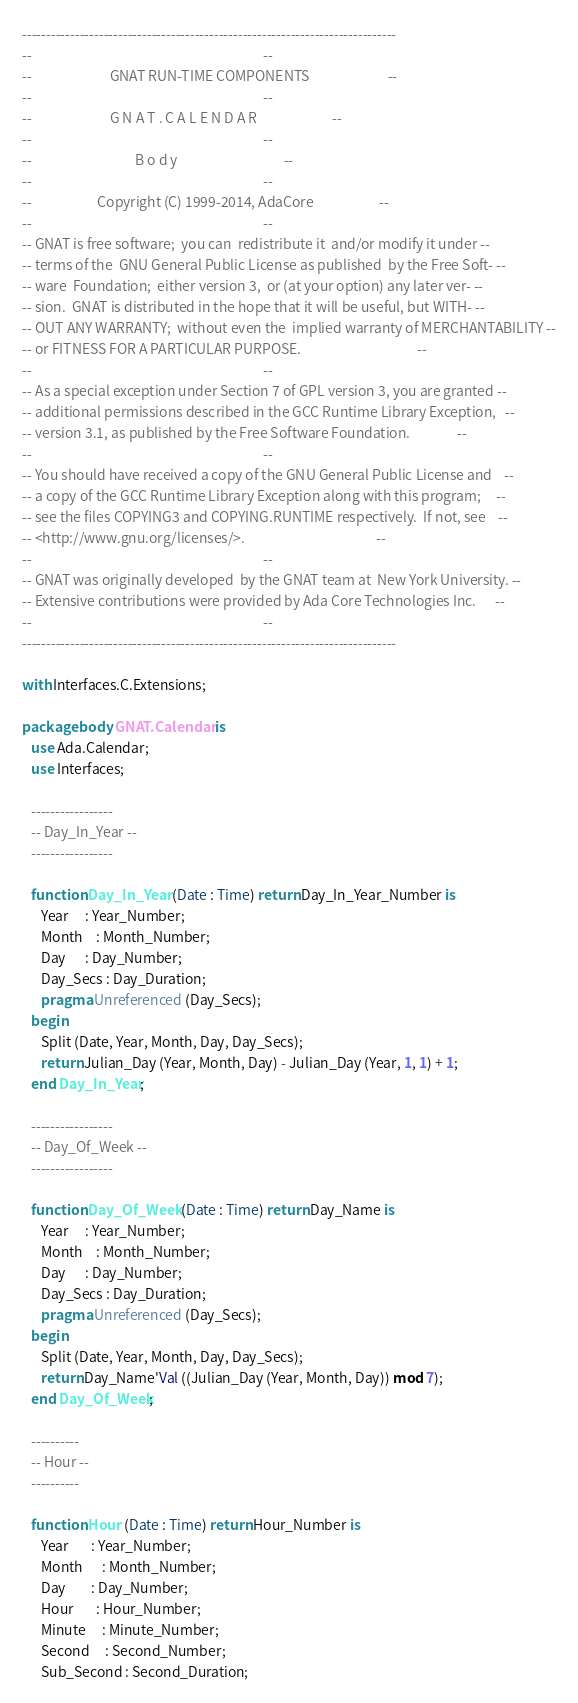<code> <loc_0><loc_0><loc_500><loc_500><_Ada_>------------------------------------------------------------------------------
--                                                                          --
--                         GNAT RUN-TIME COMPONENTS                         --
--                                                                          --
--                         G N A T . C A L E N D A R                        --
--                                                                          --
--                                 B o d y                                  --
--                                                                          --
--                     Copyright (C) 1999-2014, AdaCore                     --
--                                                                          --
-- GNAT is free software;  you can  redistribute it  and/or modify it under --
-- terms of the  GNU General Public License as published  by the Free Soft- --
-- ware  Foundation;  either version 3,  or (at your option) any later ver- --
-- sion.  GNAT is distributed in the hope that it will be useful, but WITH- --
-- OUT ANY WARRANTY;  without even the  implied warranty of MERCHANTABILITY --
-- or FITNESS FOR A PARTICULAR PURPOSE.                                     --
--                                                                          --
-- As a special exception under Section 7 of GPL version 3, you are granted --
-- additional permissions described in the GCC Runtime Library Exception,   --
-- version 3.1, as published by the Free Software Foundation.               --
--                                                                          --
-- You should have received a copy of the GNU General Public License and    --
-- a copy of the GCC Runtime Library Exception along with this program;     --
-- see the files COPYING3 and COPYING.RUNTIME respectively.  If not, see    --
-- <http://www.gnu.org/licenses/>.                                          --
--                                                                          --
-- GNAT was originally developed  by the GNAT team at  New York University. --
-- Extensive contributions were provided by Ada Core Technologies Inc.      --
--                                                                          --
------------------------------------------------------------------------------

with Interfaces.C.Extensions;

package body GNAT.Calendar is
   use Ada.Calendar;
   use Interfaces;

   -----------------
   -- Day_In_Year --
   -----------------

   function Day_In_Year (Date : Time) return Day_In_Year_Number is
      Year     : Year_Number;
      Month    : Month_Number;
      Day      : Day_Number;
      Day_Secs : Day_Duration;
      pragma Unreferenced (Day_Secs);
   begin
      Split (Date, Year, Month, Day, Day_Secs);
      return Julian_Day (Year, Month, Day) - Julian_Day (Year, 1, 1) + 1;
   end Day_In_Year;

   -----------------
   -- Day_Of_Week --
   -----------------

   function Day_Of_Week (Date : Time) return Day_Name is
      Year     : Year_Number;
      Month    : Month_Number;
      Day      : Day_Number;
      Day_Secs : Day_Duration;
      pragma Unreferenced (Day_Secs);
   begin
      Split (Date, Year, Month, Day, Day_Secs);
      return Day_Name'Val ((Julian_Day (Year, Month, Day)) mod 7);
   end Day_Of_Week;

   ----------
   -- Hour --
   ----------

   function Hour (Date : Time) return Hour_Number is
      Year       : Year_Number;
      Month      : Month_Number;
      Day        : Day_Number;
      Hour       : Hour_Number;
      Minute     : Minute_Number;
      Second     : Second_Number;
      Sub_Second : Second_Duration;</code> 